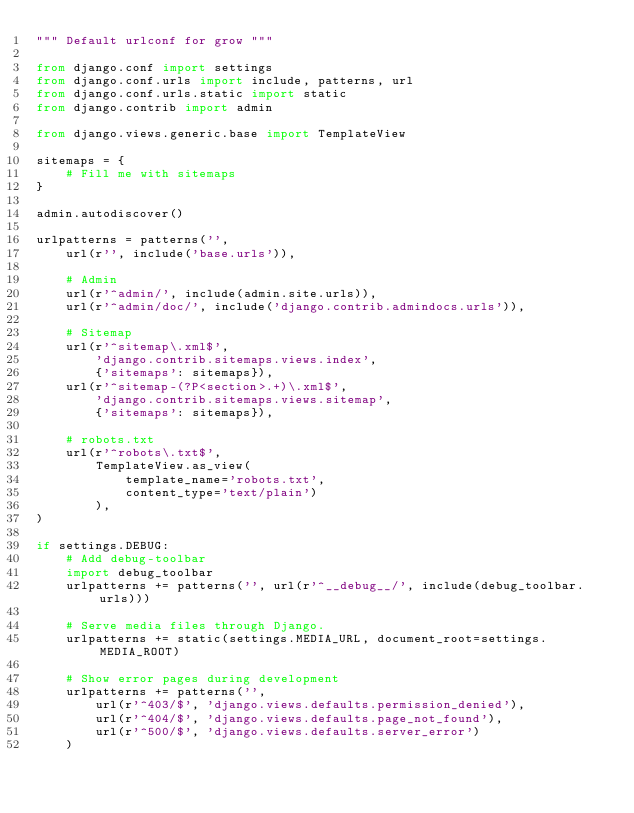Convert code to text. <code><loc_0><loc_0><loc_500><loc_500><_Python_>""" Default urlconf for grow """

from django.conf import settings
from django.conf.urls import include, patterns, url
from django.conf.urls.static import static
from django.contrib import admin

from django.views.generic.base import TemplateView

sitemaps = {
    # Fill me with sitemaps
}

admin.autodiscover()

urlpatterns = patterns('',
    url(r'', include('base.urls')),

    # Admin
    url(r'^admin/', include(admin.site.urls)),
    url(r'^admin/doc/', include('django.contrib.admindocs.urls')),

    # Sitemap
    url(r'^sitemap\.xml$',
        'django.contrib.sitemaps.views.index',
        {'sitemaps': sitemaps}),
    url(r'^sitemap-(?P<section>.+)\.xml$',
        'django.contrib.sitemaps.views.sitemap',
        {'sitemaps': sitemaps}),

    # robots.txt
    url(r'^robots\.txt$',
        TemplateView.as_view(
            template_name='robots.txt',
            content_type='text/plain')
        ),
)

if settings.DEBUG:
    # Add debug-toolbar
    import debug_toolbar
    urlpatterns += patterns('', url(r'^__debug__/', include(debug_toolbar.urls)))

    # Serve media files through Django.
    urlpatterns += static(settings.MEDIA_URL, document_root=settings.MEDIA_ROOT)

    # Show error pages during development
    urlpatterns += patterns('',
        url(r'^403/$', 'django.views.defaults.permission_denied'),
        url(r'^404/$', 'django.views.defaults.page_not_found'),
        url(r'^500/$', 'django.views.defaults.server_error')
    )
</code> 